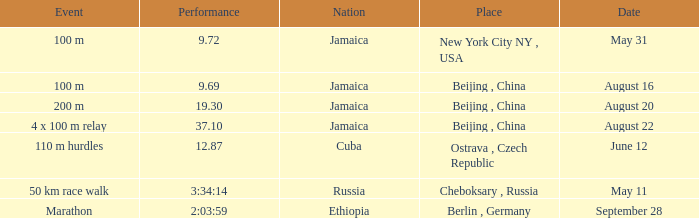Which place had a performance of 19.30 seconds by Jamaica? Beijing , China. 